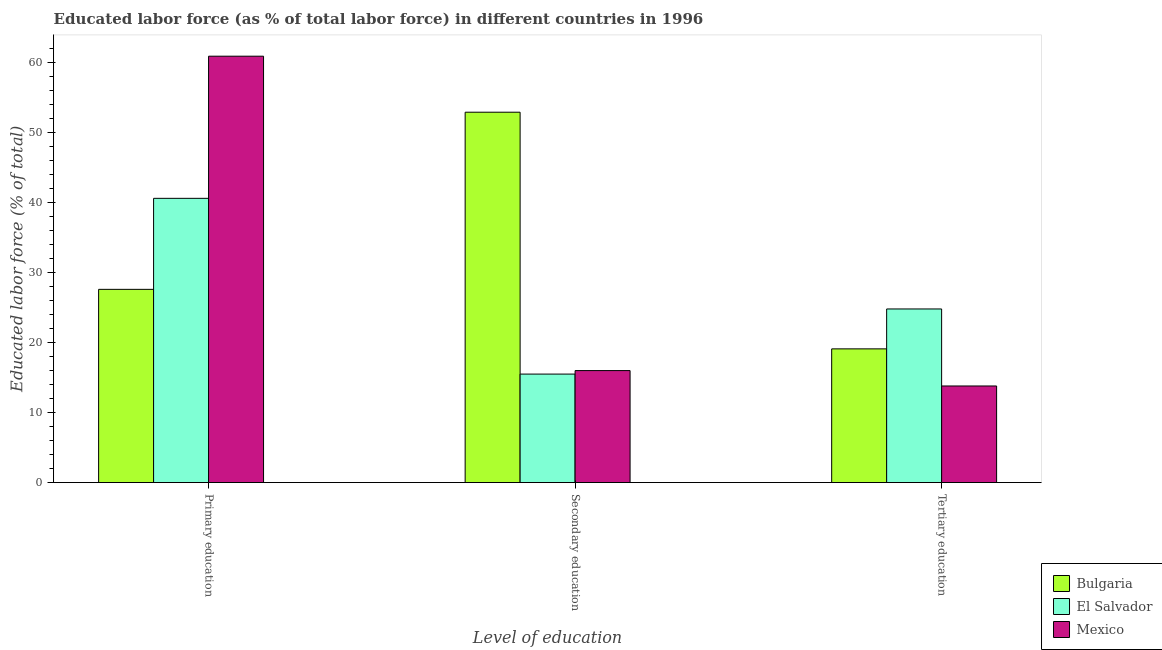Are the number of bars per tick equal to the number of legend labels?
Your response must be concise. Yes. Are the number of bars on each tick of the X-axis equal?
Your answer should be very brief. Yes. How many bars are there on the 2nd tick from the right?
Your response must be concise. 3. What is the label of the 3rd group of bars from the left?
Keep it short and to the point. Tertiary education. What is the percentage of labor force who received primary education in El Salvador?
Provide a short and direct response. 40.6. Across all countries, what is the maximum percentage of labor force who received secondary education?
Offer a terse response. 52.9. In which country was the percentage of labor force who received tertiary education maximum?
Offer a terse response. El Salvador. What is the total percentage of labor force who received primary education in the graph?
Your answer should be very brief. 129.1. What is the difference between the percentage of labor force who received primary education in Mexico and that in El Salvador?
Keep it short and to the point. 20.3. What is the difference between the percentage of labor force who received tertiary education in Bulgaria and the percentage of labor force who received primary education in Mexico?
Provide a succinct answer. -41.8. What is the average percentage of labor force who received secondary education per country?
Ensure brevity in your answer.  28.13. What is the difference between the percentage of labor force who received primary education and percentage of labor force who received tertiary education in El Salvador?
Make the answer very short. 15.8. What is the ratio of the percentage of labor force who received tertiary education in El Salvador to that in Bulgaria?
Ensure brevity in your answer.  1.3. Is the percentage of labor force who received tertiary education in El Salvador less than that in Bulgaria?
Offer a very short reply. No. Is the difference between the percentage of labor force who received tertiary education in El Salvador and Mexico greater than the difference between the percentage of labor force who received secondary education in El Salvador and Mexico?
Provide a succinct answer. Yes. What is the difference between the highest and the second highest percentage of labor force who received tertiary education?
Your response must be concise. 5.7. What is the difference between the highest and the lowest percentage of labor force who received tertiary education?
Provide a short and direct response. 11. In how many countries, is the percentage of labor force who received primary education greater than the average percentage of labor force who received primary education taken over all countries?
Give a very brief answer. 1. Is the sum of the percentage of labor force who received tertiary education in Mexico and Bulgaria greater than the maximum percentage of labor force who received primary education across all countries?
Make the answer very short. No. What does the 2nd bar from the left in Primary education represents?
Provide a succinct answer. El Salvador. How many bars are there?
Make the answer very short. 9. Are all the bars in the graph horizontal?
Your answer should be compact. No. What is the difference between two consecutive major ticks on the Y-axis?
Make the answer very short. 10. Are the values on the major ticks of Y-axis written in scientific E-notation?
Offer a very short reply. No. Does the graph contain grids?
Your answer should be very brief. No. Where does the legend appear in the graph?
Ensure brevity in your answer.  Bottom right. How are the legend labels stacked?
Your answer should be very brief. Vertical. What is the title of the graph?
Keep it short and to the point. Educated labor force (as % of total labor force) in different countries in 1996. What is the label or title of the X-axis?
Offer a terse response. Level of education. What is the label or title of the Y-axis?
Give a very brief answer. Educated labor force (% of total). What is the Educated labor force (% of total) of Bulgaria in Primary education?
Provide a short and direct response. 27.6. What is the Educated labor force (% of total) of El Salvador in Primary education?
Make the answer very short. 40.6. What is the Educated labor force (% of total) of Mexico in Primary education?
Your answer should be compact. 60.9. What is the Educated labor force (% of total) of Bulgaria in Secondary education?
Offer a terse response. 52.9. What is the Educated labor force (% of total) of Mexico in Secondary education?
Keep it short and to the point. 16. What is the Educated labor force (% of total) in Bulgaria in Tertiary education?
Make the answer very short. 19.1. What is the Educated labor force (% of total) in El Salvador in Tertiary education?
Provide a short and direct response. 24.8. What is the Educated labor force (% of total) of Mexico in Tertiary education?
Provide a short and direct response. 13.8. Across all Level of education, what is the maximum Educated labor force (% of total) in Bulgaria?
Keep it short and to the point. 52.9. Across all Level of education, what is the maximum Educated labor force (% of total) in El Salvador?
Your answer should be compact. 40.6. Across all Level of education, what is the maximum Educated labor force (% of total) in Mexico?
Keep it short and to the point. 60.9. Across all Level of education, what is the minimum Educated labor force (% of total) of Bulgaria?
Offer a terse response. 19.1. Across all Level of education, what is the minimum Educated labor force (% of total) in El Salvador?
Offer a very short reply. 15.5. Across all Level of education, what is the minimum Educated labor force (% of total) in Mexico?
Keep it short and to the point. 13.8. What is the total Educated labor force (% of total) in Bulgaria in the graph?
Keep it short and to the point. 99.6. What is the total Educated labor force (% of total) in El Salvador in the graph?
Offer a very short reply. 80.9. What is the total Educated labor force (% of total) in Mexico in the graph?
Provide a succinct answer. 90.7. What is the difference between the Educated labor force (% of total) of Bulgaria in Primary education and that in Secondary education?
Your answer should be compact. -25.3. What is the difference between the Educated labor force (% of total) of El Salvador in Primary education and that in Secondary education?
Your answer should be very brief. 25.1. What is the difference between the Educated labor force (% of total) of Mexico in Primary education and that in Secondary education?
Give a very brief answer. 44.9. What is the difference between the Educated labor force (% of total) in Bulgaria in Primary education and that in Tertiary education?
Provide a succinct answer. 8.5. What is the difference between the Educated labor force (% of total) of Mexico in Primary education and that in Tertiary education?
Give a very brief answer. 47.1. What is the difference between the Educated labor force (% of total) of Bulgaria in Secondary education and that in Tertiary education?
Offer a very short reply. 33.8. What is the difference between the Educated labor force (% of total) of Bulgaria in Primary education and the Educated labor force (% of total) of El Salvador in Secondary education?
Your response must be concise. 12.1. What is the difference between the Educated labor force (% of total) in Bulgaria in Primary education and the Educated labor force (% of total) in Mexico in Secondary education?
Provide a short and direct response. 11.6. What is the difference between the Educated labor force (% of total) in El Salvador in Primary education and the Educated labor force (% of total) in Mexico in Secondary education?
Ensure brevity in your answer.  24.6. What is the difference between the Educated labor force (% of total) of El Salvador in Primary education and the Educated labor force (% of total) of Mexico in Tertiary education?
Your response must be concise. 26.8. What is the difference between the Educated labor force (% of total) in Bulgaria in Secondary education and the Educated labor force (% of total) in El Salvador in Tertiary education?
Offer a very short reply. 28.1. What is the difference between the Educated labor force (% of total) in Bulgaria in Secondary education and the Educated labor force (% of total) in Mexico in Tertiary education?
Offer a terse response. 39.1. What is the difference between the Educated labor force (% of total) of El Salvador in Secondary education and the Educated labor force (% of total) of Mexico in Tertiary education?
Offer a very short reply. 1.7. What is the average Educated labor force (% of total) in Bulgaria per Level of education?
Keep it short and to the point. 33.2. What is the average Educated labor force (% of total) of El Salvador per Level of education?
Your answer should be compact. 26.97. What is the average Educated labor force (% of total) in Mexico per Level of education?
Give a very brief answer. 30.23. What is the difference between the Educated labor force (% of total) of Bulgaria and Educated labor force (% of total) of Mexico in Primary education?
Provide a short and direct response. -33.3. What is the difference between the Educated labor force (% of total) in El Salvador and Educated labor force (% of total) in Mexico in Primary education?
Provide a short and direct response. -20.3. What is the difference between the Educated labor force (% of total) in Bulgaria and Educated labor force (% of total) in El Salvador in Secondary education?
Provide a short and direct response. 37.4. What is the difference between the Educated labor force (% of total) in Bulgaria and Educated labor force (% of total) in Mexico in Secondary education?
Offer a terse response. 36.9. What is the difference between the Educated labor force (% of total) in El Salvador and Educated labor force (% of total) in Mexico in Secondary education?
Your answer should be very brief. -0.5. What is the difference between the Educated labor force (% of total) of El Salvador and Educated labor force (% of total) of Mexico in Tertiary education?
Offer a terse response. 11. What is the ratio of the Educated labor force (% of total) of Bulgaria in Primary education to that in Secondary education?
Your answer should be compact. 0.52. What is the ratio of the Educated labor force (% of total) in El Salvador in Primary education to that in Secondary education?
Offer a terse response. 2.62. What is the ratio of the Educated labor force (% of total) in Mexico in Primary education to that in Secondary education?
Your response must be concise. 3.81. What is the ratio of the Educated labor force (% of total) of Bulgaria in Primary education to that in Tertiary education?
Make the answer very short. 1.45. What is the ratio of the Educated labor force (% of total) in El Salvador in Primary education to that in Tertiary education?
Give a very brief answer. 1.64. What is the ratio of the Educated labor force (% of total) in Mexico in Primary education to that in Tertiary education?
Your answer should be very brief. 4.41. What is the ratio of the Educated labor force (% of total) of Bulgaria in Secondary education to that in Tertiary education?
Provide a succinct answer. 2.77. What is the ratio of the Educated labor force (% of total) of El Salvador in Secondary education to that in Tertiary education?
Make the answer very short. 0.62. What is the ratio of the Educated labor force (% of total) in Mexico in Secondary education to that in Tertiary education?
Keep it short and to the point. 1.16. What is the difference between the highest and the second highest Educated labor force (% of total) of Bulgaria?
Keep it short and to the point. 25.3. What is the difference between the highest and the second highest Educated labor force (% of total) in El Salvador?
Provide a succinct answer. 15.8. What is the difference between the highest and the second highest Educated labor force (% of total) in Mexico?
Your response must be concise. 44.9. What is the difference between the highest and the lowest Educated labor force (% of total) of Bulgaria?
Make the answer very short. 33.8. What is the difference between the highest and the lowest Educated labor force (% of total) of El Salvador?
Your response must be concise. 25.1. What is the difference between the highest and the lowest Educated labor force (% of total) in Mexico?
Keep it short and to the point. 47.1. 